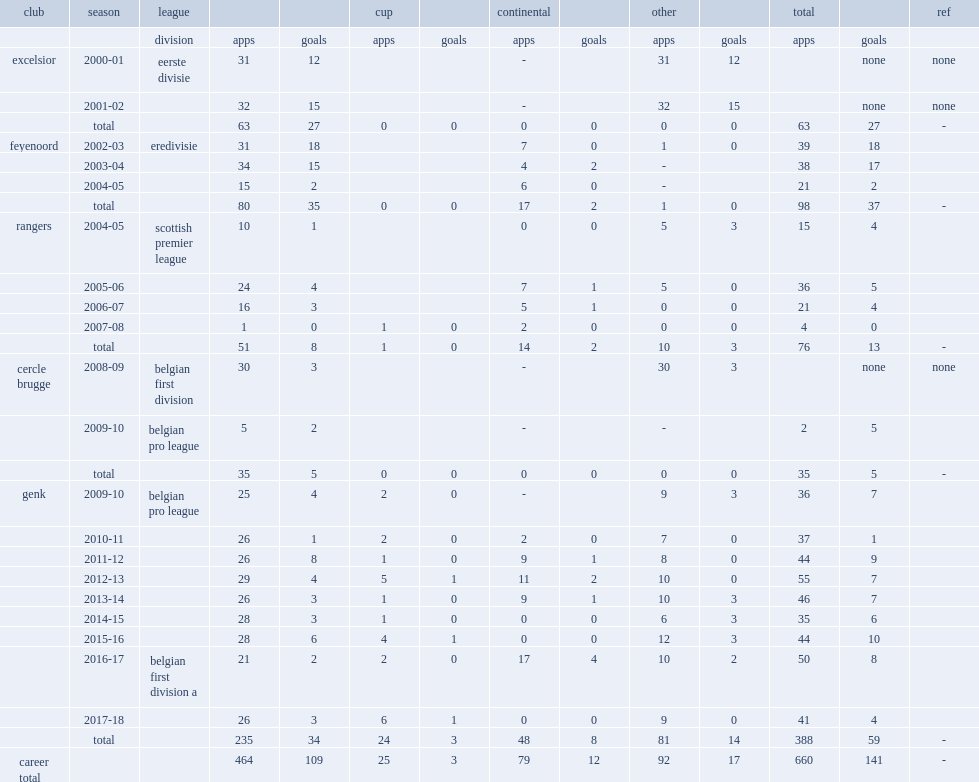In the 2002-03 season, which league did thomas buffel play for feyenoord in? Eredivisie. 